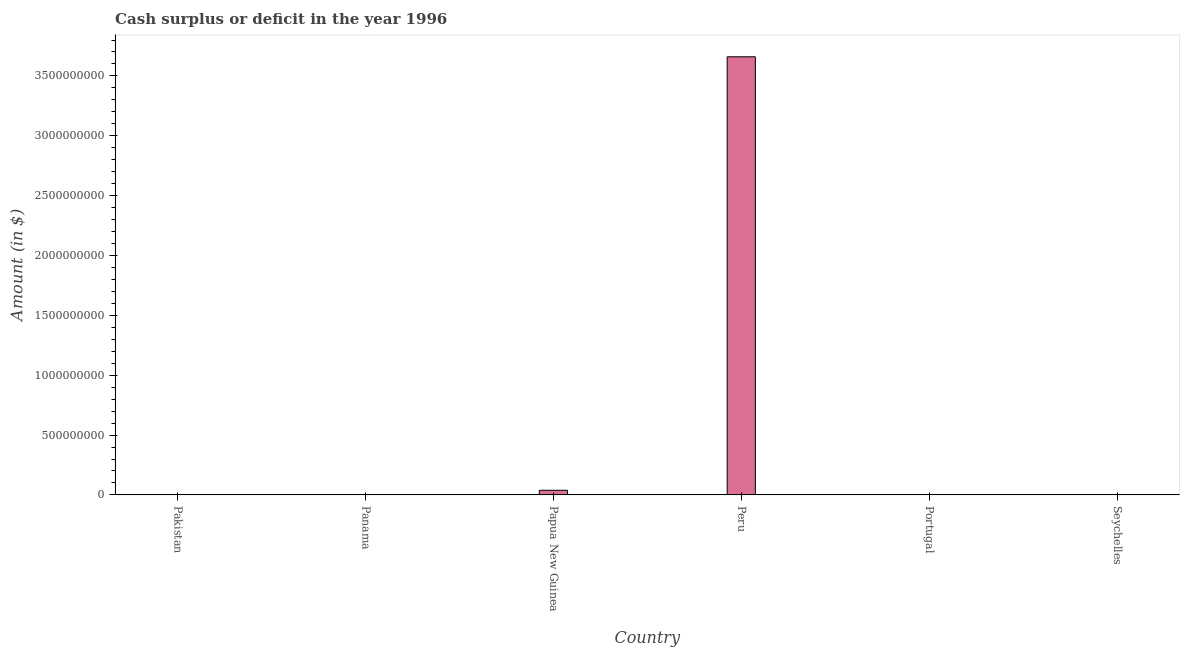Does the graph contain any zero values?
Offer a terse response. Yes. Does the graph contain grids?
Your answer should be very brief. No. What is the title of the graph?
Offer a very short reply. Cash surplus or deficit in the year 1996. What is the label or title of the Y-axis?
Offer a very short reply. Amount (in $). What is the cash surplus or deficit in Pakistan?
Keep it short and to the point. 0. Across all countries, what is the maximum cash surplus or deficit?
Make the answer very short. 3.66e+09. What is the sum of the cash surplus or deficit?
Offer a very short reply. 3.70e+09. What is the difference between the cash surplus or deficit in Papua New Guinea and Peru?
Your answer should be very brief. -3.62e+09. What is the average cash surplus or deficit per country?
Offer a terse response. 6.16e+08. What is the median cash surplus or deficit?
Keep it short and to the point. 0. What is the difference between the highest and the lowest cash surplus or deficit?
Your answer should be very brief. 3.66e+09. How many countries are there in the graph?
Your answer should be very brief. 6. What is the difference between two consecutive major ticks on the Y-axis?
Your answer should be very brief. 5.00e+08. Are the values on the major ticks of Y-axis written in scientific E-notation?
Ensure brevity in your answer.  No. What is the Amount (in $) of Papua New Guinea?
Your answer should be compact. 3.88e+07. What is the Amount (in $) of Peru?
Ensure brevity in your answer.  3.66e+09. What is the difference between the Amount (in $) in Papua New Guinea and Peru?
Keep it short and to the point. -3.62e+09. What is the ratio of the Amount (in $) in Papua New Guinea to that in Peru?
Give a very brief answer. 0.01. 